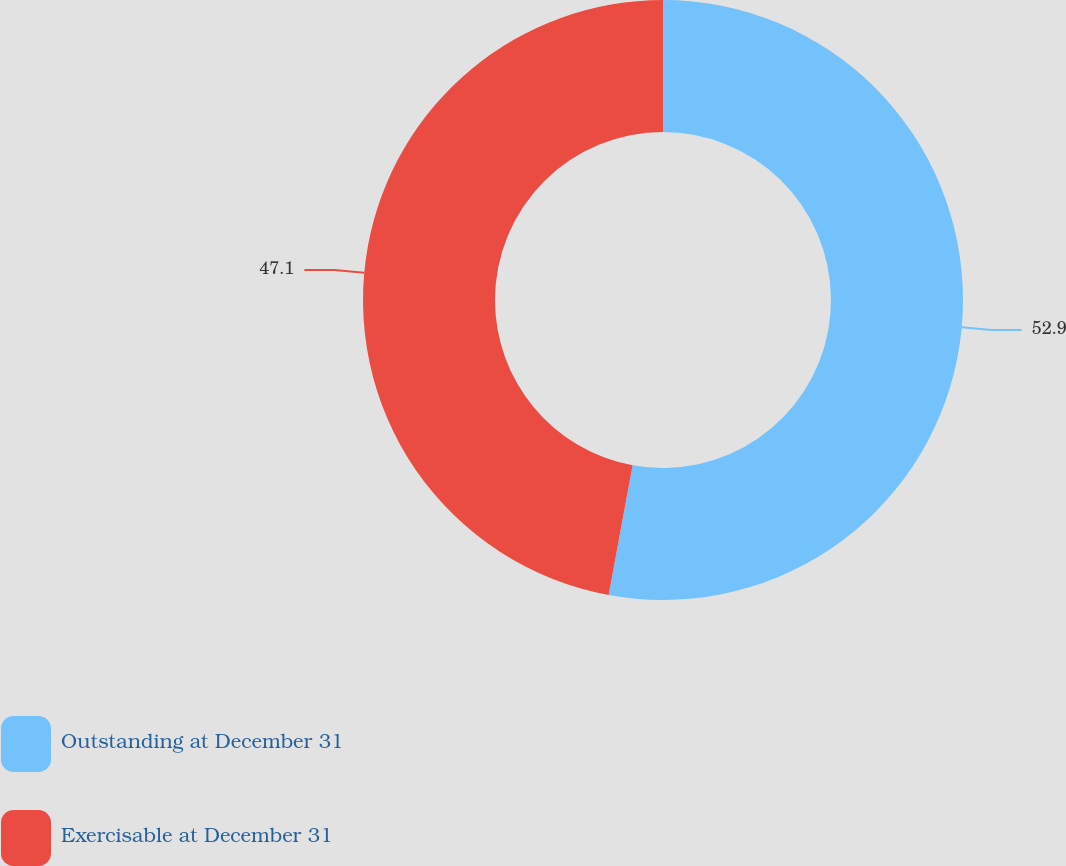<chart> <loc_0><loc_0><loc_500><loc_500><pie_chart><fcel>Outstanding at December 31<fcel>Exercisable at December 31<nl><fcel>52.9%<fcel>47.1%<nl></chart> 